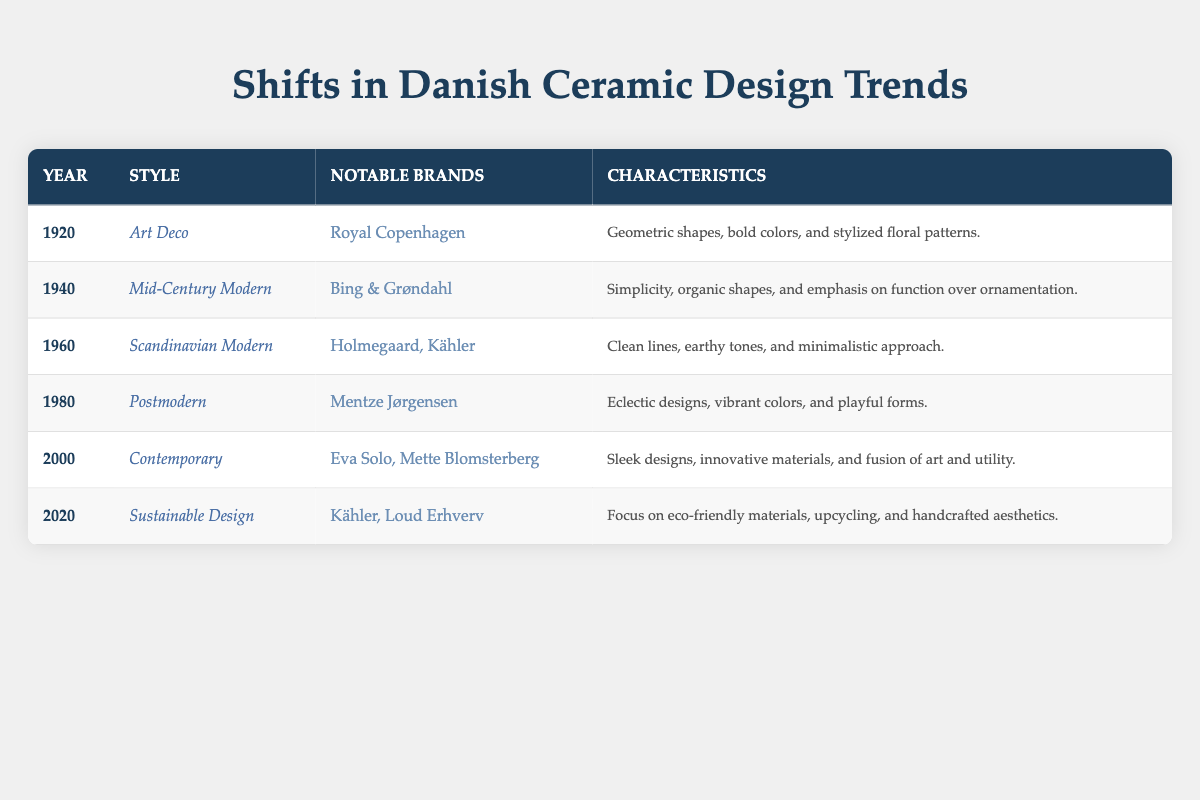What was the ceramic design style in Denmark in 1980? According to the table, the style of ceramic design in Denmark in 1980 was Postmodern.
Answer: Postmodern Which notable brand is associated with the Art Deco style? The table lists Royal Copenhagen as the notable brand connected to the Art Deco style in 1920.
Answer: Royal Copenhagen Did the style of ceramic design shift to Sustainable Design by the year 2020? Yes, the table indicates that by 2020, the style of ceramic design in Denmark had shifted to Sustainable Design.
Answer: Yes How many years separated the Mid-Century Modern style from the Contemporary style? To find the years separating these styles, we look at the years in the table. Mid-Century Modern is from 1940 and Contemporary is from 2000. The difference is 2000 - 1940 = 60 years.
Answer: 60 years What are the key characteristics of Scandinavian Modern design? The table states that the characteristics of Scandinavian Modern design include clean lines, earthy tones, and a minimalistic approach, as listed for 1960.
Answer: Clean lines, earthy tones, minimalistic approach Which period had an emphasis on simplicity and function over ornamentation? According to the table, the Mid-Century Modern style from 1940 is characterized by an emphasis on simplicity and function over ornamentation.
Answer: Mid-Century Modern Are Holmegaard and Kähler associated with the same ceramic design style? Yes, both Holmegaard and Kähler are noted as associated brands under the Scandinavian Modern style from 1960 in the table.
Answer: Yes What is the trend observed in the characteristics of designs from 1920 to 2020 in terms of environmental consciousness? The characteristics evolve from bold and artistic designs in 1920, moving towards innovative and function-focused designs, ultimately culminating in a focus on eco-friendly materials and handcrafted aesthetics by 2020.
Answer: From bold to eco-friendly In which year did the shift towards eco-friendly materials start? The table shows that the focus on eco-friendly materials began with the Sustainable Design style in 2020.
Answer: 2020 